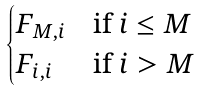<formula> <loc_0><loc_0><loc_500><loc_500>\begin{cases} F _ { M , i } & \text {if } i \leq M \\ F _ { i , i } & \text {if } i > M \end{cases}</formula> 